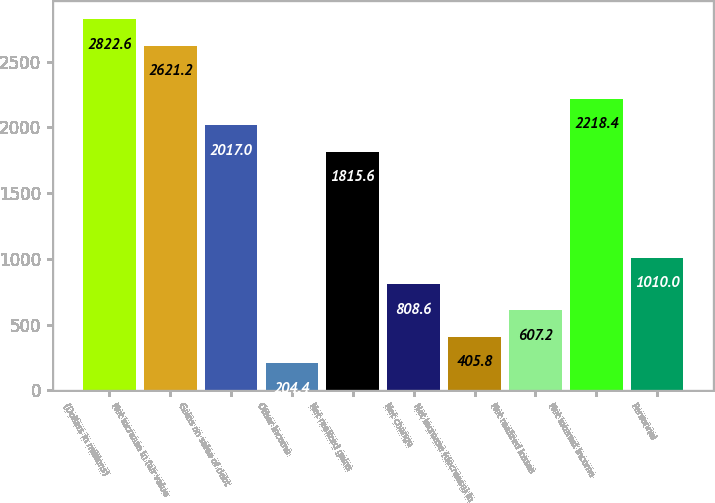Convert chart to OTSL. <chart><loc_0><loc_0><loc_500><loc_500><bar_chart><fcel>(Dollars in millions)<fcel>Net increase in fair value<fcel>Gains on sales of debt<fcel>Other income<fcel>Net realized gains<fcel>Net change<fcel>Net increase (decrease) in<fcel>Net realized losses<fcel>Net interest income<fcel>Personnel<nl><fcel>2822.6<fcel>2621.2<fcel>2017<fcel>204.4<fcel>1815.6<fcel>808.6<fcel>405.8<fcel>607.2<fcel>2218.4<fcel>1010<nl></chart> 